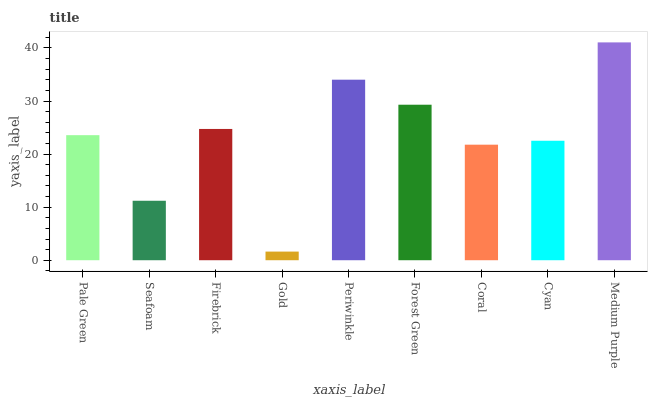Is Gold the minimum?
Answer yes or no. Yes. Is Medium Purple the maximum?
Answer yes or no. Yes. Is Seafoam the minimum?
Answer yes or no. No. Is Seafoam the maximum?
Answer yes or no. No. Is Pale Green greater than Seafoam?
Answer yes or no. Yes. Is Seafoam less than Pale Green?
Answer yes or no. Yes. Is Seafoam greater than Pale Green?
Answer yes or no. No. Is Pale Green less than Seafoam?
Answer yes or no. No. Is Pale Green the high median?
Answer yes or no. Yes. Is Pale Green the low median?
Answer yes or no. Yes. Is Forest Green the high median?
Answer yes or no. No. Is Firebrick the low median?
Answer yes or no. No. 